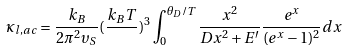Convert formula to latex. <formula><loc_0><loc_0><loc_500><loc_500>\kappa _ { l , a c } = \frac { k _ { B } } { 2 \pi ^ { 2 } \upsilon _ { S } } ( \frac { k _ { B } T } { } ) ^ { 3 } \int _ { 0 } ^ { \theta _ { D } / T } \frac { x ^ { 2 } } { D x ^ { 2 } + E ^ { \prime } } \frac { e ^ { x } } { ( e ^ { x } - 1 ) ^ { 2 } } d x</formula> 